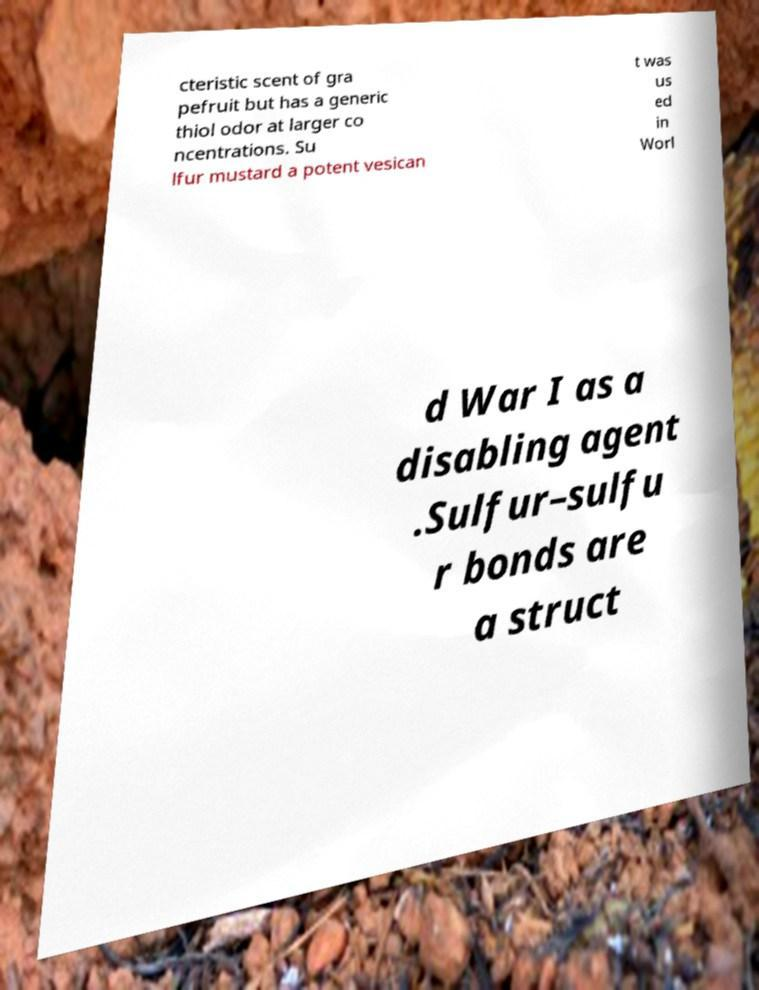What messages or text are displayed in this image? I need them in a readable, typed format. cteristic scent of gra pefruit but has a generic thiol odor at larger co ncentrations. Su lfur mustard a potent vesican t was us ed in Worl d War I as a disabling agent .Sulfur–sulfu r bonds are a struct 